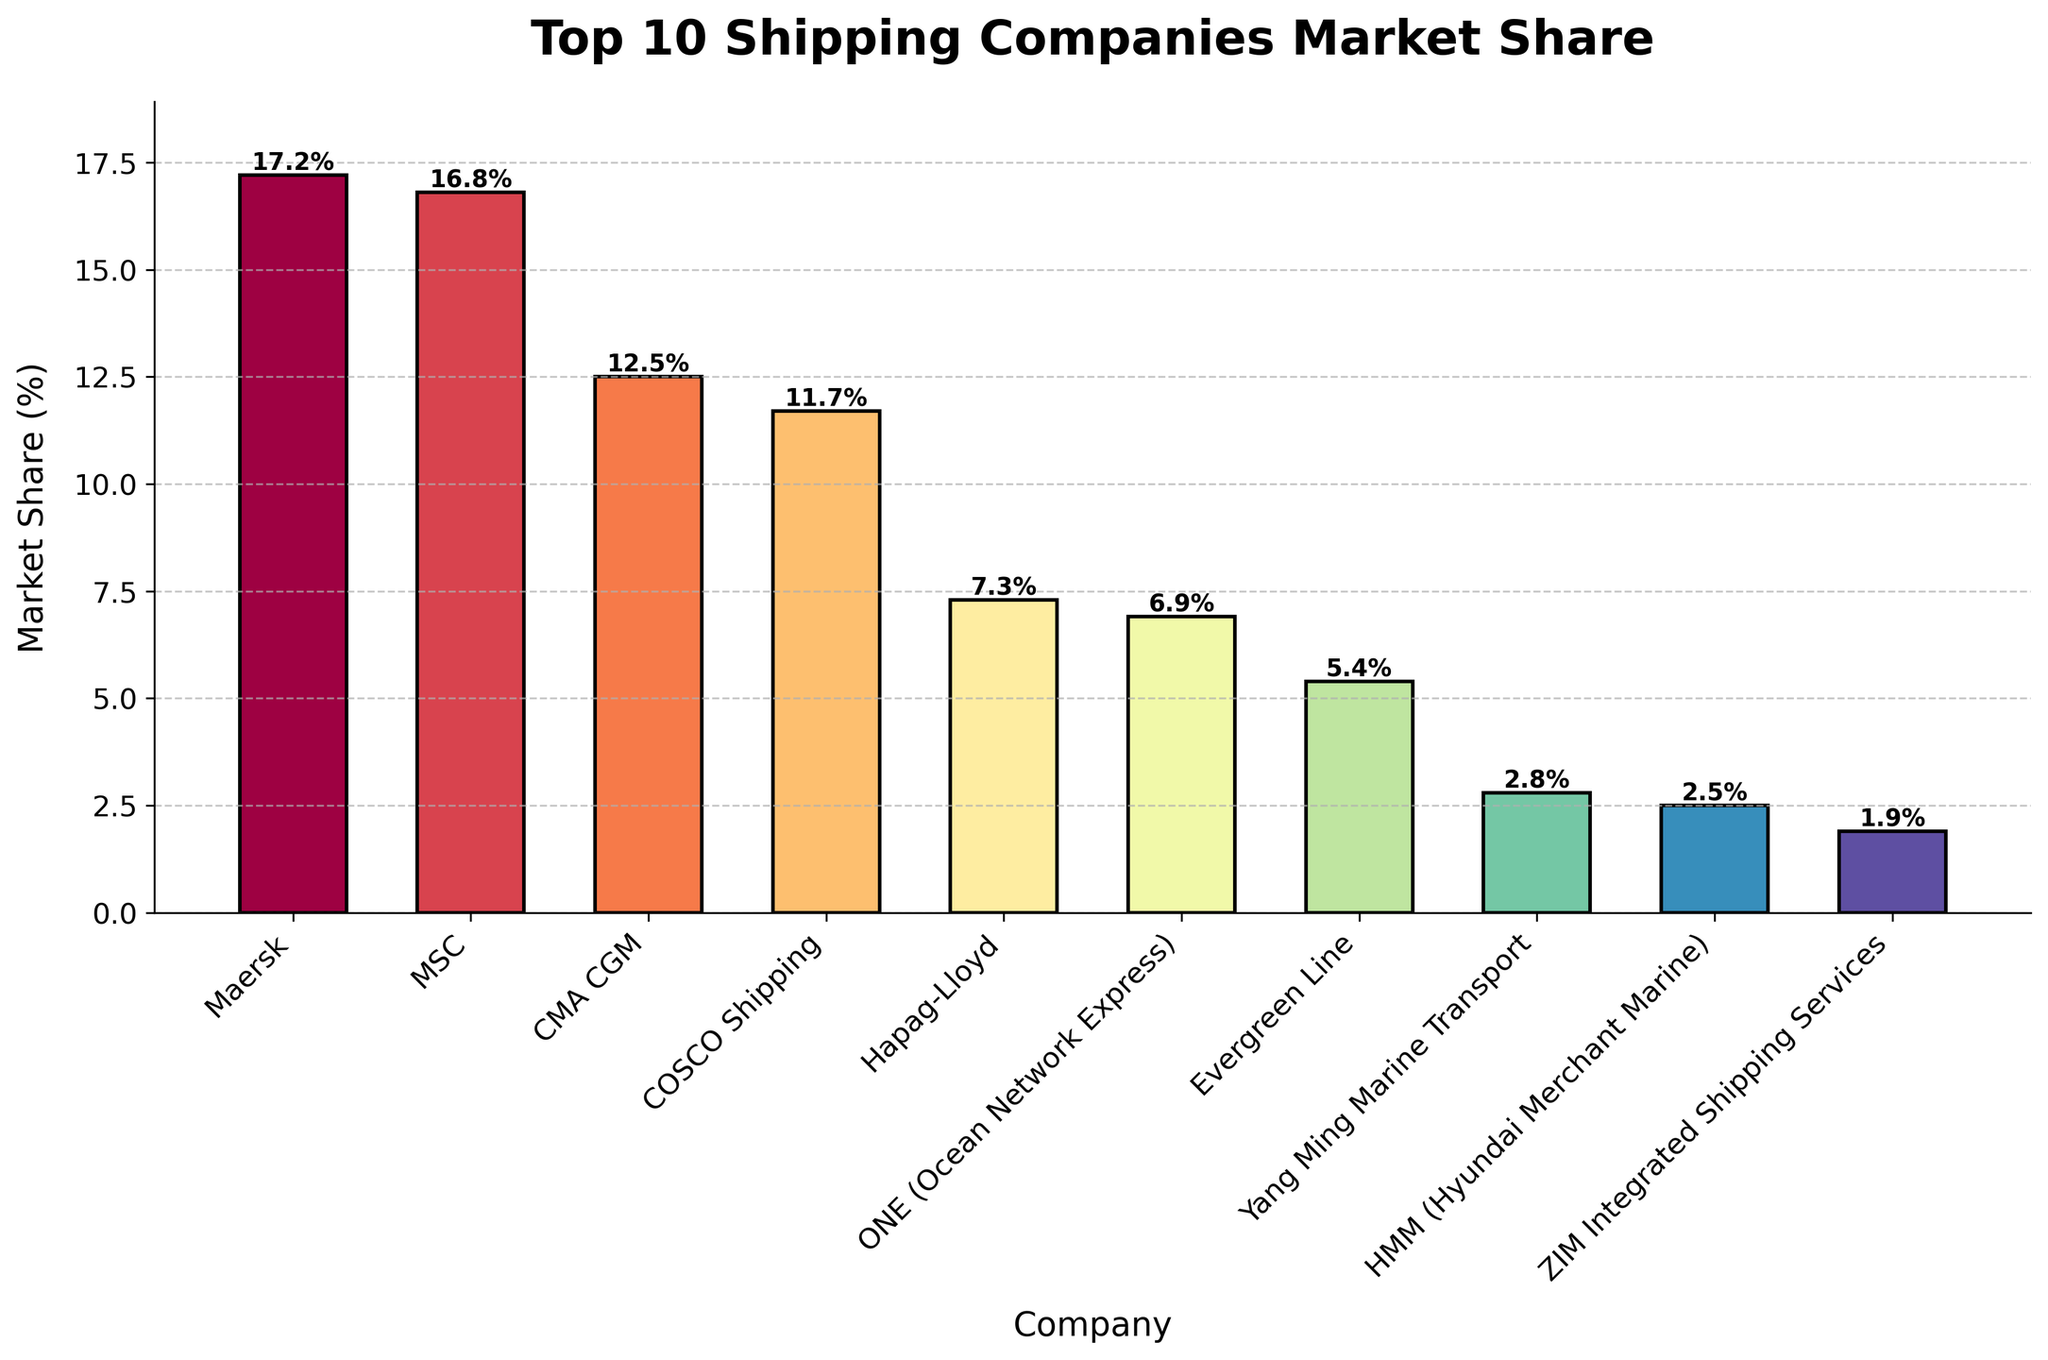What's the company with the highest market share? Check the heights of the bars. The tallest bar corresponds to Maersk.
Answer: Maersk What is the combined market share of CMA CGM and COSCO Shipping? Add the market shares of CMA CGM (12.5%) and COSCO Shipping (11.7%) together. 12.5% + 11.7% = 24.2%
Answer: 24.2% Which company has a market share less than 2%? Look for the bar that is lower than the 2% mark. ZIM Integrated Shipping Services has a market share of 1.9%.
Answer: ZIM Integrated Shipping Services Which two companies have nearly equal market shares? Identify bars with similar heights. Maersk and MSC have market shares of 17.2% and 16.8%, respectively.
Answer: Maersk and MSC What's the difference in market share between Hapag-Lloyd and Yang Ming Marine Transport? Subtract the market share of Yang Ming Marine Transport (2.8%) from Hapag-Lloyd (7.3%). 7.3% - 2.8% = 4.5%
Answer: 4.5% How many companies have a market share greater than 10%? Count the number of bars taller than the 10% mark. Four companies: Maersk, MSC, CMA CGM, and COSCO Shipping.
Answer: Four Which company has the shortest bar? Identify the shortest bar. ZIM Integrated Shipping Services has the lowest market share at 1.9%.
Answer: ZIM Integrated Shipping Services What is the average market share of the top three companies? Add the market shares of the top three companies (Maersk: 17.2%, MSC: 16.8%, CMA CGM: 12.5%) and divide by 3. (17.2 + 16.8 + 12.5) / 3 ≈ 15.5%
Answer: 15.5% What's the combined market share of companies with a market share below 5%? Add the market shares of Evergreen Line (5.4%), Yang Ming Marine Transport (2.8%), HMM (2.5%), and ZIM Integrated Shipping Services (1.9%). 5.4% + 2.8% + 2.5% + 1.9% = 12.6%
Answer: 12.6% 